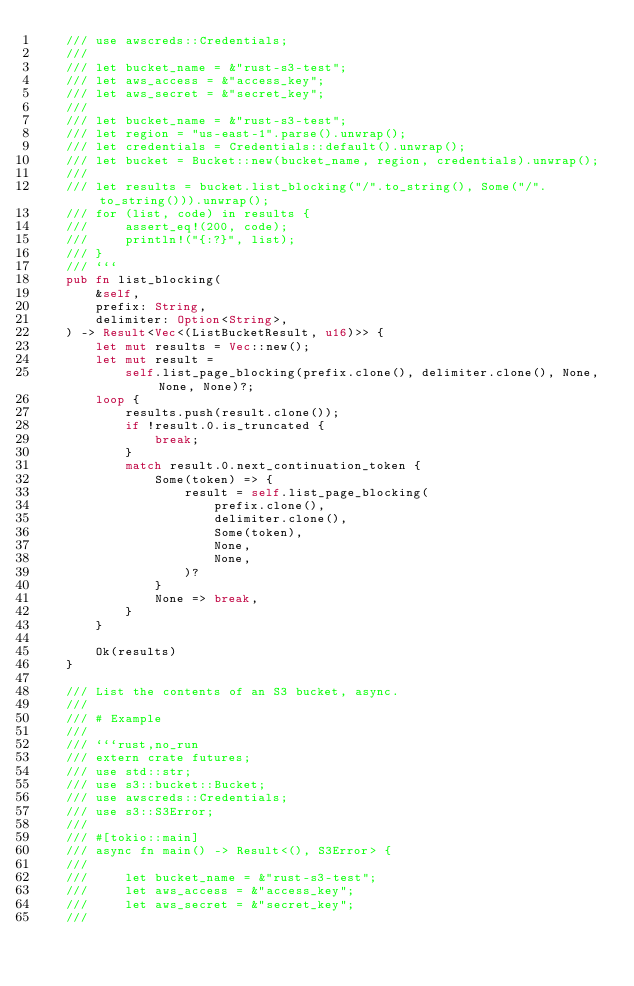Convert code to text. <code><loc_0><loc_0><loc_500><loc_500><_Rust_>    /// use awscreds::Credentials;
    ///
    /// let bucket_name = &"rust-s3-test";
    /// let aws_access = &"access_key";
    /// let aws_secret = &"secret_key";
    ///
    /// let bucket_name = &"rust-s3-test";
    /// let region = "us-east-1".parse().unwrap();
    /// let credentials = Credentials::default().unwrap();
    /// let bucket = Bucket::new(bucket_name, region, credentials).unwrap();
    ///
    /// let results = bucket.list_blocking("/".to_string(), Some("/".to_string())).unwrap();
    /// for (list, code) in results {
    ///     assert_eq!(200, code);
    ///     println!("{:?}", list);
    /// }
    /// ```
    pub fn list_blocking(
        &self,
        prefix: String,
        delimiter: Option<String>,
    ) -> Result<Vec<(ListBucketResult, u16)>> {
        let mut results = Vec::new();
        let mut result =
            self.list_page_blocking(prefix.clone(), delimiter.clone(), None, None, None)?;
        loop {
            results.push(result.clone());
            if !result.0.is_truncated {
                break;
            }
            match result.0.next_continuation_token {
                Some(token) => {
                    result = self.list_page_blocking(
                        prefix.clone(),
                        delimiter.clone(),
                        Some(token),
                        None,
                        None,
                    )?
                }
                None => break,
            }
        }

        Ok(results)
    }

    /// List the contents of an S3 bucket, async.
    ///
    /// # Example
    ///
    /// ```rust,no_run
    /// extern crate futures;
    /// use std::str;
    /// use s3::bucket::Bucket;
    /// use awscreds::Credentials;
    /// use s3::S3Error;
    ///
    /// #[tokio::main]
    /// async fn main() -> Result<(), S3Error> {
    ///
    ///     let bucket_name = &"rust-s3-test";
    ///     let aws_access = &"access_key";
    ///     let aws_secret = &"secret_key";
    ///</code> 